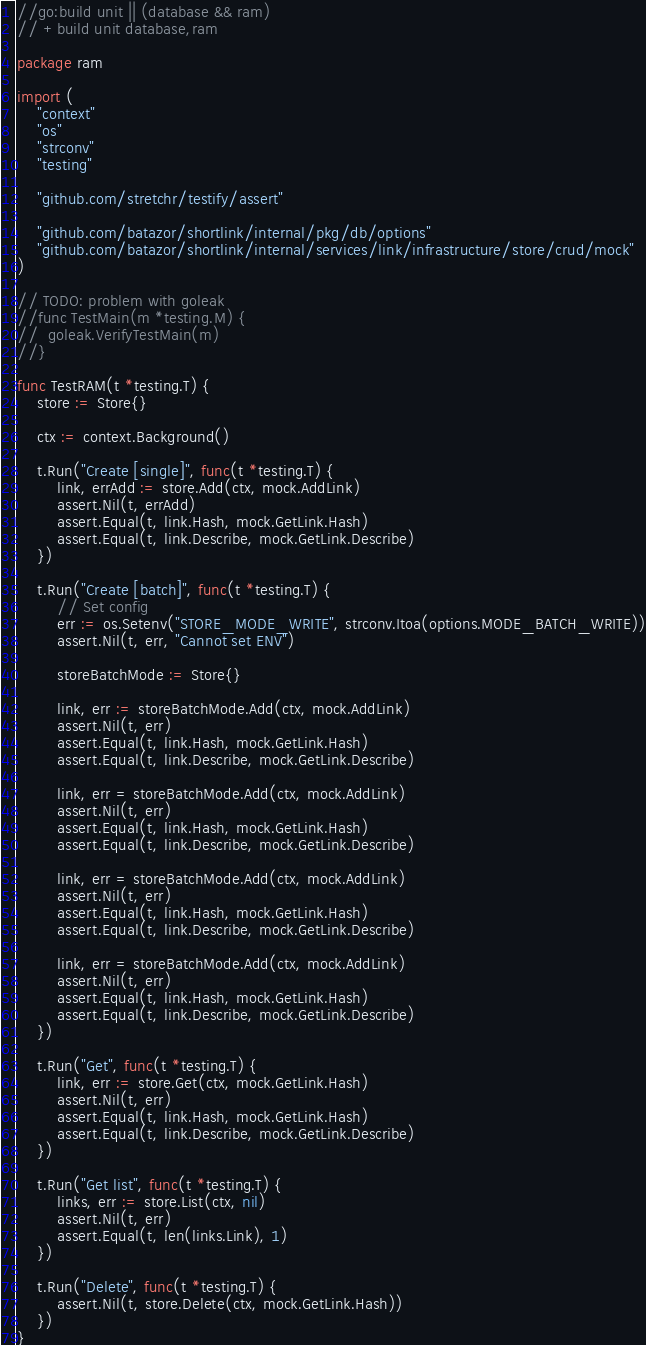Convert code to text. <code><loc_0><loc_0><loc_500><loc_500><_Go_>//go:build unit || (database && ram)
// +build unit database,ram

package ram

import (
	"context"
	"os"
	"strconv"
	"testing"

	"github.com/stretchr/testify/assert"

	"github.com/batazor/shortlink/internal/pkg/db/options"
	"github.com/batazor/shortlink/internal/services/link/infrastructure/store/crud/mock"
)

// TODO: problem with goleak
//func TestMain(m *testing.M) {
//	goleak.VerifyTestMain(m)
//}

func TestRAM(t *testing.T) {
	store := Store{}

	ctx := context.Background()

	t.Run("Create [single]", func(t *testing.T) {
		link, errAdd := store.Add(ctx, mock.AddLink)
		assert.Nil(t, errAdd)
		assert.Equal(t, link.Hash, mock.GetLink.Hash)
		assert.Equal(t, link.Describe, mock.GetLink.Describe)
	})

	t.Run("Create [batch]", func(t *testing.T) {
		// Set config
		err := os.Setenv("STORE_MODE_WRITE", strconv.Itoa(options.MODE_BATCH_WRITE))
		assert.Nil(t, err, "Cannot set ENV")

		storeBatchMode := Store{}

		link, err := storeBatchMode.Add(ctx, mock.AddLink)
		assert.Nil(t, err)
		assert.Equal(t, link.Hash, mock.GetLink.Hash)
		assert.Equal(t, link.Describe, mock.GetLink.Describe)

		link, err = storeBatchMode.Add(ctx, mock.AddLink)
		assert.Nil(t, err)
		assert.Equal(t, link.Hash, mock.GetLink.Hash)
		assert.Equal(t, link.Describe, mock.GetLink.Describe)

		link, err = storeBatchMode.Add(ctx, mock.AddLink)
		assert.Nil(t, err)
		assert.Equal(t, link.Hash, mock.GetLink.Hash)
		assert.Equal(t, link.Describe, mock.GetLink.Describe)

		link, err = storeBatchMode.Add(ctx, mock.AddLink)
		assert.Nil(t, err)
		assert.Equal(t, link.Hash, mock.GetLink.Hash)
		assert.Equal(t, link.Describe, mock.GetLink.Describe)
	})

	t.Run("Get", func(t *testing.T) {
		link, err := store.Get(ctx, mock.GetLink.Hash)
		assert.Nil(t, err)
		assert.Equal(t, link.Hash, mock.GetLink.Hash)
		assert.Equal(t, link.Describe, mock.GetLink.Describe)
	})

	t.Run("Get list", func(t *testing.T) {
		links, err := store.List(ctx, nil)
		assert.Nil(t, err)
		assert.Equal(t, len(links.Link), 1)
	})

	t.Run("Delete", func(t *testing.T) {
		assert.Nil(t, store.Delete(ctx, mock.GetLink.Hash))
	})
}
</code> 